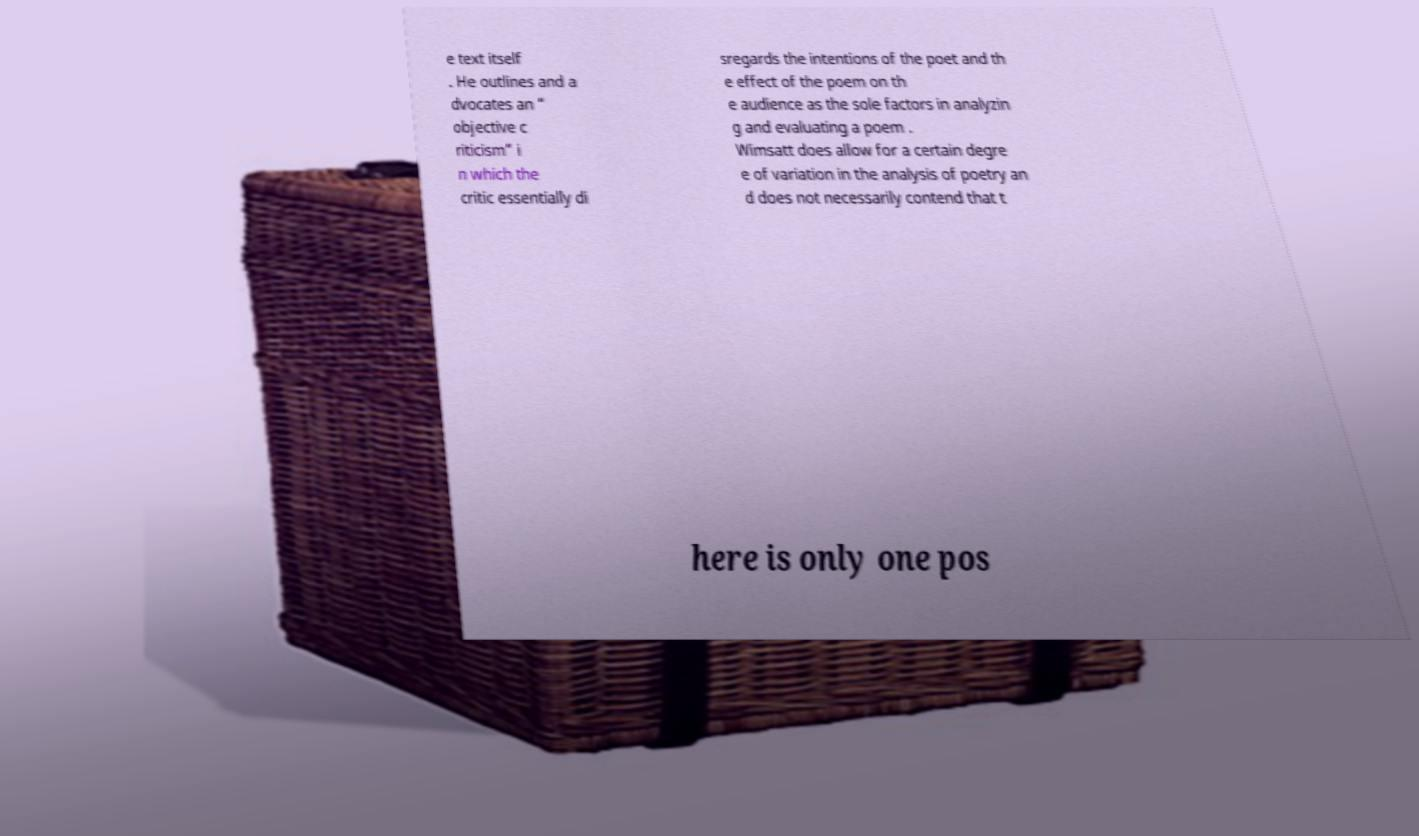Please read and relay the text visible in this image. What does it say? e text itself . He outlines and a dvocates an “ objective c riticism” i n which the critic essentially di sregards the intentions of the poet and th e effect of the poem on th e audience as the sole factors in analyzin g and evaluating a poem . Wimsatt does allow for a certain degre e of variation in the analysis of poetry an d does not necessarily contend that t here is only one pos 